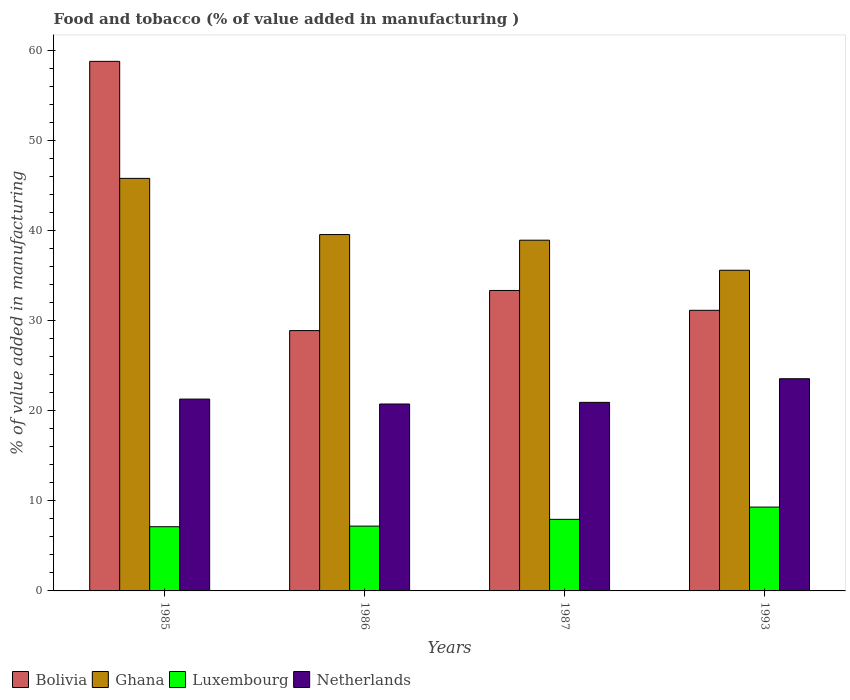How many different coloured bars are there?
Provide a succinct answer. 4. How many groups of bars are there?
Your answer should be compact. 4. Are the number of bars per tick equal to the number of legend labels?
Keep it short and to the point. Yes. Are the number of bars on each tick of the X-axis equal?
Provide a short and direct response. Yes. How many bars are there on the 4th tick from the left?
Your answer should be very brief. 4. How many bars are there on the 1st tick from the right?
Your response must be concise. 4. What is the label of the 4th group of bars from the left?
Provide a succinct answer. 1993. What is the value added in manufacturing food and tobacco in Netherlands in 1993?
Provide a succinct answer. 23.54. Across all years, what is the maximum value added in manufacturing food and tobacco in Ghana?
Ensure brevity in your answer.  45.76. Across all years, what is the minimum value added in manufacturing food and tobacco in Netherlands?
Provide a short and direct response. 20.73. What is the total value added in manufacturing food and tobacco in Luxembourg in the graph?
Your answer should be very brief. 31.56. What is the difference between the value added in manufacturing food and tobacco in Ghana in 1986 and that in 1993?
Offer a terse response. 3.96. What is the difference between the value added in manufacturing food and tobacco in Ghana in 1993 and the value added in manufacturing food and tobacco in Bolivia in 1985?
Make the answer very short. -23.18. What is the average value added in manufacturing food and tobacco in Luxembourg per year?
Your response must be concise. 7.89. In the year 1993, what is the difference between the value added in manufacturing food and tobacco in Ghana and value added in manufacturing food and tobacco in Bolivia?
Your answer should be very brief. 4.44. What is the ratio of the value added in manufacturing food and tobacco in Luxembourg in 1986 to that in 1993?
Give a very brief answer. 0.77. What is the difference between the highest and the second highest value added in manufacturing food and tobacco in Ghana?
Offer a terse response. 6.23. What is the difference between the highest and the lowest value added in manufacturing food and tobacco in Bolivia?
Provide a succinct answer. 29.87. In how many years, is the value added in manufacturing food and tobacco in Luxembourg greater than the average value added in manufacturing food and tobacco in Luxembourg taken over all years?
Your answer should be compact. 2. Is the sum of the value added in manufacturing food and tobacco in Bolivia in 1985 and 1987 greater than the maximum value added in manufacturing food and tobacco in Luxembourg across all years?
Your response must be concise. Yes. Is it the case that in every year, the sum of the value added in manufacturing food and tobacco in Ghana and value added in manufacturing food and tobacco in Luxembourg is greater than the value added in manufacturing food and tobacco in Bolivia?
Provide a succinct answer. No. How many bars are there?
Ensure brevity in your answer.  16. Are all the bars in the graph horizontal?
Provide a succinct answer. No. How many years are there in the graph?
Ensure brevity in your answer.  4. Are the values on the major ticks of Y-axis written in scientific E-notation?
Give a very brief answer. No. How many legend labels are there?
Keep it short and to the point. 4. What is the title of the graph?
Provide a succinct answer. Food and tobacco (% of value added in manufacturing ). What is the label or title of the Y-axis?
Your response must be concise. % of value added in manufacturing. What is the % of value added in manufacturing in Bolivia in 1985?
Ensure brevity in your answer.  58.75. What is the % of value added in manufacturing of Ghana in 1985?
Provide a succinct answer. 45.76. What is the % of value added in manufacturing in Luxembourg in 1985?
Keep it short and to the point. 7.12. What is the % of value added in manufacturing in Netherlands in 1985?
Give a very brief answer. 21.28. What is the % of value added in manufacturing in Bolivia in 1986?
Offer a very short reply. 28.88. What is the % of value added in manufacturing of Ghana in 1986?
Provide a succinct answer. 39.53. What is the % of value added in manufacturing of Luxembourg in 1986?
Provide a succinct answer. 7.19. What is the % of value added in manufacturing in Netherlands in 1986?
Offer a very short reply. 20.73. What is the % of value added in manufacturing in Bolivia in 1987?
Offer a very short reply. 33.33. What is the % of value added in manufacturing of Ghana in 1987?
Your answer should be very brief. 38.91. What is the % of value added in manufacturing in Luxembourg in 1987?
Your response must be concise. 7.94. What is the % of value added in manufacturing of Netherlands in 1987?
Your answer should be compact. 20.92. What is the % of value added in manufacturing of Bolivia in 1993?
Offer a terse response. 31.13. What is the % of value added in manufacturing of Ghana in 1993?
Ensure brevity in your answer.  35.57. What is the % of value added in manufacturing of Luxembourg in 1993?
Your answer should be very brief. 9.3. What is the % of value added in manufacturing in Netherlands in 1993?
Ensure brevity in your answer.  23.54. Across all years, what is the maximum % of value added in manufacturing in Bolivia?
Give a very brief answer. 58.75. Across all years, what is the maximum % of value added in manufacturing in Ghana?
Offer a terse response. 45.76. Across all years, what is the maximum % of value added in manufacturing in Luxembourg?
Your answer should be very brief. 9.3. Across all years, what is the maximum % of value added in manufacturing in Netherlands?
Provide a succinct answer. 23.54. Across all years, what is the minimum % of value added in manufacturing of Bolivia?
Ensure brevity in your answer.  28.88. Across all years, what is the minimum % of value added in manufacturing in Ghana?
Your response must be concise. 35.57. Across all years, what is the minimum % of value added in manufacturing in Luxembourg?
Provide a succinct answer. 7.12. Across all years, what is the minimum % of value added in manufacturing in Netherlands?
Offer a terse response. 20.73. What is the total % of value added in manufacturing of Bolivia in the graph?
Provide a short and direct response. 152.09. What is the total % of value added in manufacturing in Ghana in the graph?
Your response must be concise. 159.77. What is the total % of value added in manufacturing of Luxembourg in the graph?
Provide a succinct answer. 31.56. What is the total % of value added in manufacturing in Netherlands in the graph?
Your answer should be compact. 86.47. What is the difference between the % of value added in manufacturing of Bolivia in 1985 and that in 1986?
Ensure brevity in your answer.  29.87. What is the difference between the % of value added in manufacturing of Ghana in 1985 and that in 1986?
Ensure brevity in your answer.  6.23. What is the difference between the % of value added in manufacturing in Luxembourg in 1985 and that in 1986?
Ensure brevity in your answer.  -0.07. What is the difference between the % of value added in manufacturing in Netherlands in 1985 and that in 1986?
Provide a succinct answer. 0.55. What is the difference between the % of value added in manufacturing in Bolivia in 1985 and that in 1987?
Provide a succinct answer. 25.42. What is the difference between the % of value added in manufacturing of Ghana in 1985 and that in 1987?
Your answer should be compact. 6.86. What is the difference between the % of value added in manufacturing of Luxembourg in 1985 and that in 1987?
Make the answer very short. -0.82. What is the difference between the % of value added in manufacturing of Netherlands in 1985 and that in 1987?
Give a very brief answer. 0.36. What is the difference between the % of value added in manufacturing in Bolivia in 1985 and that in 1993?
Provide a short and direct response. 27.62. What is the difference between the % of value added in manufacturing in Ghana in 1985 and that in 1993?
Your response must be concise. 10.19. What is the difference between the % of value added in manufacturing of Luxembourg in 1985 and that in 1993?
Offer a terse response. -2.18. What is the difference between the % of value added in manufacturing in Netherlands in 1985 and that in 1993?
Offer a very short reply. -2.26. What is the difference between the % of value added in manufacturing of Bolivia in 1986 and that in 1987?
Your answer should be very brief. -4.45. What is the difference between the % of value added in manufacturing in Ghana in 1986 and that in 1987?
Your answer should be very brief. 0.63. What is the difference between the % of value added in manufacturing of Luxembourg in 1986 and that in 1987?
Offer a very short reply. -0.75. What is the difference between the % of value added in manufacturing in Netherlands in 1986 and that in 1987?
Your answer should be very brief. -0.18. What is the difference between the % of value added in manufacturing of Bolivia in 1986 and that in 1993?
Your response must be concise. -2.25. What is the difference between the % of value added in manufacturing of Ghana in 1986 and that in 1993?
Your answer should be compact. 3.96. What is the difference between the % of value added in manufacturing in Luxembourg in 1986 and that in 1993?
Give a very brief answer. -2.11. What is the difference between the % of value added in manufacturing in Netherlands in 1986 and that in 1993?
Make the answer very short. -2.8. What is the difference between the % of value added in manufacturing in Bolivia in 1987 and that in 1993?
Your answer should be very brief. 2.2. What is the difference between the % of value added in manufacturing of Ghana in 1987 and that in 1993?
Ensure brevity in your answer.  3.34. What is the difference between the % of value added in manufacturing in Luxembourg in 1987 and that in 1993?
Offer a terse response. -1.36. What is the difference between the % of value added in manufacturing in Netherlands in 1987 and that in 1993?
Provide a succinct answer. -2.62. What is the difference between the % of value added in manufacturing of Bolivia in 1985 and the % of value added in manufacturing of Ghana in 1986?
Ensure brevity in your answer.  19.21. What is the difference between the % of value added in manufacturing of Bolivia in 1985 and the % of value added in manufacturing of Luxembourg in 1986?
Ensure brevity in your answer.  51.56. What is the difference between the % of value added in manufacturing in Bolivia in 1985 and the % of value added in manufacturing in Netherlands in 1986?
Your answer should be compact. 38.01. What is the difference between the % of value added in manufacturing in Ghana in 1985 and the % of value added in manufacturing in Luxembourg in 1986?
Your answer should be very brief. 38.57. What is the difference between the % of value added in manufacturing in Ghana in 1985 and the % of value added in manufacturing in Netherlands in 1986?
Offer a very short reply. 25.03. What is the difference between the % of value added in manufacturing of Luxembourg in 1985 and the % of value added in manufacturing of Netherlands in 1986?
Make the answer very short. -13.61. What is the difference between the % of value added in manufacturing of Bolivia in 1985 and the % of value added in manufacturing of Ghana in 1987?
Offer a terse response. 19.84. What is the difference between the % of value added in manufacturing of Bolivia in 1985 and the % of value added in manufacturing of Luxembourg in 1987?
Ensure brevity in your answer.  50.81. What is the difference between the % of value added in manufacturing in Bolivia in 1985 and the % of value added in manufacturing in Netherlands in 1987?
Keep it short and to the point. 37.83. What is the difference between the % of value added in manufacturing in Ghana in 1985 and the % of value added in manufacturing in Luxembourg in 1987?
Ensure brevity in your answer.  37.82. What is the difference between the % of value added in manufacturing of Ghana in 1985 and the % of value added in manufacturing of Netherlands in 1987?
Offer a very short reply. 24.85. What is the difference between the % of value added in manufacturing in Luxembourg in 1985 and the % of value added in manufacturing in Netherlands in 1987?
Your response must be concise. -13.79. What is the difference between the % of value added in manufacturing of Bolivia in 1985 and the % of value added in manufacturing of Ghana in 1993?
Provide a succinct answer. 23.18. What is the difference between the % of value added in manufacturing in Bolivia in 1985 and the % of value added in manufacturing in Luxembourg in 1993?
Give a very brief answer. 49.45. What is the difference between the % of value added in manufacturing in Bolivia in 1985 and the % of value added in manufacturing in Netherlands in 1993?
Give a very brief answer. 35.21. What is the difference between the % of value added in manufacturing in Ghana in 1985 and the % of value added in manufacturing in Luxembourg in 1993?
Provide a short and direct response. 36.46. What is the difference between the % of value added in manufacturing in Ghana in 1985 and the % of value added in manufacturing in Netherlands in 1993?
Ensure brevity in your answer.  22.22. What is the difference between the % of value added in manufacturing in Luxembourg in 1985 and the % of value added in manufacturing in Netherlands in 1993?
Offer a very short reply. -16.42. What is the difference between the % of value added in manufacturing of Bolivia in 1986 and the % of value added in manufacturing of Ghana in 1987?
Offer a terse response. -10.03. What is the difference between the % of value added in manufacturing of Bolivia in 1986 and the % of value added in manufacturing of Luxembourg in 1987?
Your response must be concise. 20.94. What is the difference between the % of value added in manufacturing of Bolivia in 1986 and the % of value added in manufacturing of Netherlands in 1987?
Provide a succinct answer. 7.96. What is the difference between the % of value added in manufacturing of Ghana in 1986 and the % of value added in manufacturing of Luxembourg in 1987?
Offer a terse response. 31.59. What is the difference between the % of value added in manufacturing in Ghana in 1986 and the % of value added in manufacturing in Netherlands in 1987?
Provide a short and direct response. 18.62. What is the difference between the % of value added in manufacturing of Luxembourg in 1986 and the % of value added in manufacturing of Netherlands in 1987?
Provide a short and direct response. -13.73. What is the difference between the % of value added in manufacturing in Bolivia in 1986 and the % of value added in manufacturing in Ghana in 1993?
Provide a short and direct response. -6.69. What is the difference between the % of value added in manufacturing of Bolivia in 1986 and the % of value added in manufacturing of Luxembourg in 1993?
Provide a short and direct response. 19.58. What is the difference between the % of value added in manufacturing of Bolivia in 1986 and the % of value added in manufacturing of Netherlands in 1993?
Provide a succinct answer. 5.34. What is the difference between the % of value added in manufacturing of Ghana in 1986 and the % of value added in manufacturing of Luxembourg in 1993?
Ensure brevity in your answer.  30.23. What is the difference between the % of value added in manufacturing of Ghana in 1986 and the % of value added in manufacturing of Netherlands in 1993?
Make the answer very short. 15.99. What is the difference between the % of value added in manufacturing in Luxembourg in 1986 and the % of value added in manufacturing in Netherlands in 1993?
Make the answer very short. -16.35. What is the difference between the % of value added in manufacturing in Bolivia in 1987 and the % of value added in manufacturing in Ghana in 1993?
Provide a short and direct response. -2.24. What is the difference between the % of value added in manufacturing in Bolivia in 1987 and the % of value added in manufacturing in Luxembourg in 1993?
Your answer should be compact. 24.03. What is the difference between the % of value added in manufacturing in Bolivia in 1987 and the % of value added in manufacturing in Netherlands in 1993?
Ensure brevity in your answer.  9.79. What is the difference between the % of value added in manufacturing in Ghana in 1987 and the % of value added in manufacturing in Luxembourg in 1993?
Your response must be concise. 29.61. What is the difference between the % of value added in manufacturing of Ghana in 1987 and the % of value added in manufacturing of Netherlands in 1993?
Make the answer very short. 15.37. What is the difference between the % of value added in manufacturing in Luxembourg in 1987 and the % of value added in manufacturing in Netherlands in 1993?
Offer a terse response. -15.6. What is the average % of value added in manufacturing of Bolivia per year?
Offer a terse response. 38.02. What is the average % of value added in manufacturing of Ghana per year?
Your answer should be compact. 39.94. What is the average % of value added in manufacturing of Luxembourg per year?
Give a very brief answer. 7.89. What is the average % of value added in manufacturing of Netherlands per year?
Keep it short and to the point. 21.62. In the year 1985, what is the difference between the % of value added in manufacturing in Bolivia and % of value added in manufacturing in Ghana?
Provide a short and direct response. 12.98. In the year 1985, what is the difference between the % of value added in manufacturing in Bolivia and % of value added in manufacturing in Luxembourg?
Provide a succinct answer. 51.62. In the year 1985, what is the difference between the % of value added in manufacturing of Bolivia and % of value added in manufacturing of Netherlands?
Make the answer very short. 37.47. In the year 1985, what is the difference between the % of value added in manufacturing in Ghana and % of value added in manufacturing in Luxembourg?
Provide a succinct answer. 38.64. In the year 1985, what is the difference between the % of value added in manufacturing of Ghana and % of value added in manufacturing of Netherlands?
Ensure brevity in your answer.  24.48. In the year 1985, what is the difference between the % of value added in manufacturing in Luxembourg and % of value added in manufacturing in Netherlands?
Your answer should be very brief. -14.16. In the year 1986, what is the difference between the % of value added in manufacturing in Bolivia and % of value added in manufacturing in Ghana?
Ensure brevity in your answer.  -10.65. In the year 1986, what is the difference between the % of value added in manufacturing of Bolivia and % of value added in manufacturing of Luxembourg?
Offer a terse response. 21.69. In the year 1986, what is the difference between the % of value added in manufacturing of Bolivia and % of value added in manufacturing of Netherlands?
Your response must be concise. 8.15. In the year 1986, what is the difference between the % of value added in manufacturing in Ghana and % of value added in manufacturing in Luxembourg?
Offer a very short reply. 32.34. In the year 1986, what is the difference between the % of value added in manufacturing of Ghana and % of value added in manufacturing of Netherlands?
Give a very brief answer. 18.8. In the year 1986, what is the difference between the % of value added in manufacturing of Luxembourg and % of value added in manufacturing of Netherlands?
Ensure brevity in your answer.  -13.54. In the year 1987, what is the difference between the % of value added in manufacturing of Bolivia and % of value added in manufacturing of Ghana?
Provide a succinct answer. -5.58. In the year 1987, what is the difference between the % of value added in manufacturing in Bolivia and % of value added in manufacturing in Luxembourg?
Keep it short and to the point. 25.39. In the year 1987, what is the difference between the % of value added in manufacturing of Bolivia and % of value added in manufacturing of Netherlands?
Provide a short and direct response. 12.41. In the year 1987, what is the difference between the % of value added in manufacturing in Ghana and % of value added in manufacturing in Luxembourg?
Keep it short and to the point. 30.97. In the year 1987, what is the difference between the % of value added in manufacturing of Ghana and % of value added in manufacturing of Netherlands?
Make the answer very short. 17.99. In the year 1987, what is the difference between the % of value added in manufacturing in Luxembourg and % of value added in manufacturing in Netherlands?
Your answer should be compact. -12.98. In the year 1993, what is the difference between the % of value added in manufacturing in Bolivia and % of value added in manufacturing in Ghana?
Provide a short and direct response. -4.44. In the year 1993, what is the difference between the % of value added in manufacturing in Bolivia and % of value added in manufacturing in Luxembourg?
Offer a terse response. 21.83. In the year 1993, what is the difference between the % of value added in manufacturing of Bolivia and % of value added in manufacturing of Netherlands?
Provide a succinct answer. 7.59. In the year 1993, what is the difference between the % of value added in manufacturing in Ghana and % of value added in manufacturing in Luxembourg?
Ensure brevity in your answer.  26.27. In the year 1993, what is the difference between the % of value added in manufacturing in Ghana and % of value added in manufacturing in Netherlands?
Offer a very short reply. 12.03. In the year 1993, what is the difference between the % of value added in manufacturing in Luxembourg and % of value added in manufacturing in Netherlands?
Offer a terse response. -14.24. What is the ratio of the % of value added in manufacturing in Bolivia in 1985 to that in 1986?
Your response must be concise. 2.03. What is the ratio of the % of value added in manufacturing in Ghana in 1985 to that in 1986?
Offer a terse response. 1.16. What is the ratio of the % of value added in manufacturing of Luxembourg in 1985 to that in 1986?
Ensure brevity in your answer.  0.99. What is the ratio of the % of value added in manufacturing of Netherlands in 1985 to that in 1986?
Provide a short and direct response. 1.03. What is the ratio of the % of value added in manufacturing in Bolivia in 1985 to that in 1987?
Offer a terse response. 1.76. What is the ratio of the % of value added in manufacturing of Ghana in 1985 to that in 1987?
Give a very brief answer. 1.18. What is the ratio of the % of value added in manufacturing of Luxembourg in 1985 to that in 1987?
Your answer should be very brief. 0.9. What is the ratio of the % of value added in manufacturing in Netherlands in 1985 to that in 1987?
Offer a terse response. 1.02. What is the ratio of the % of value added in manufacturing in Bolivia in 1985 to that in 1993?
Your answer should be compact. 1.89. What is the ratio of the % of value added in manufacturing in Ghana in 1985 to that in 1993?
Your answer should be compact. 1.29. What is the ratio of the % of value added in manufacturing of Luxembourg in 1985 to that in 1993?
Give a very brief answer. 0.77. What is the ratio of the % of value added in manufacturing in Netherlands in 1985 to that in 1993?
Ensure brevity in your answer.  0.9. What is the ratio of the % of value added in manufacturing in Bolivia in 1986 to that in 1987?
Your response must be concise. 0.87. What is the ratio of the % of value added in manufacturing of Ghana in 1986 to that in 1987?
Keep it short and to the point. 1.02. What is the ratio of the % of value added in manufacturing in Luxembourg in 1986 to that in 1987?
Make the answer very short. 0.91. What is the ratio of the % of value added in manufacturing of Netherlands in 1986 to that in 1987?
Make the answer very short. 0.99. What is the ratio of the % of value added in manufacturing in Bolivia in 1986 to that in 1993?
Give a very brief answer. 0.93. What is the ratio of the % of value added in manufacturing in Ghana in 1986 to that in 1993?
Your response must be concise. 1.11. What is the ratio of the % of value added in manufacturing of Luxembourg in 1986 to that in 1993?
Offer a terse response. 0.77. What is the ratio of the % of value added in manufacturing in Netherlands in 1986 to that in 1993?
Offer a terse response. 0.88. What is the ratio of the % of value added in manufacturing of Bolivia in 1987 to that in 1993?
Your answer should be very brief. 1.07. What is the ratio of the % of value added in manufacturing in Ghana in 1987 to that in 1993?
Provide a succinct answer. 1.09. What is the ratio of the % of value added in manufacturing of Luxembourg in 1987 to that in 1993?
Offer a terse response. 0.85. What is the ratio of the % of value added in manufacturing of Netherlands in 1987 to that in 1993?
Keep it short and to the point. 0.89. What is the difference between the highest and the second highest % of value added in manufacturing in Bolivia?
Your answer should be compact. 25.42. What is the difference between the highest and the second highest % of value added in manufacturing in Ghana?
Your answer should be very brief. 6.23. What is the difference between the highest and the second highest % of value added in manufacturing in Luxembourg?
Make the answer very short. 1.36. What is the difference between the highest and the second highest % of value added in manufacturing in Netherlands?
Your response must be concise. 2.26. What is the difference between the highest and the lowest % of value added in manufacturing in Bolivia?
Your response must be concise. 29.87. What is the difference between the highest and the lowest % of value added in manufacturing in Ghana?
Ensure brevity in your answer.  10.19. What is the difference between the highest and the lowest % of value added in manufacturing of Luxembourg?
Provide a succinct answer. 2.18. What is the difference between the highest and the lowest % of value added in manufacturing in Netherlands?
Your answer should be compact. 2.8. 